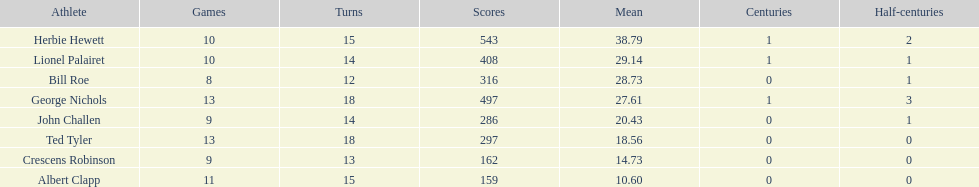Which player had the least amount of runs? Albert Clapp. 